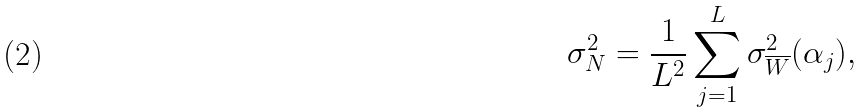Convert formula to latex. <formula><loc_0><loc_0><loc_500><loc_500>\sigma _ { N } ^ { 2 } = \frac { 1 } { L ^ { 2 } } \sum _ { j = 1 } ^ { L } \sigma ^ { 2 } _ { \overline { W } } ( \alpha _ { j } ) ,</formula> 